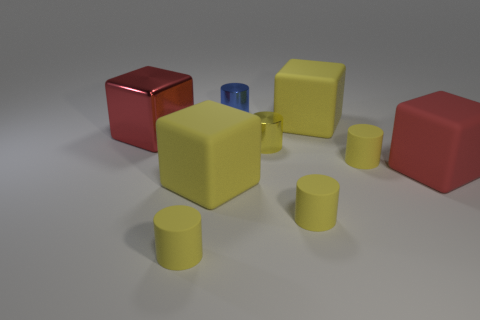How many yellow cylinders must be subtracted to get 1 yellow cylinders? 3 Subtract all cyan balls. How many yellow cylinders are left? 4 Subtract all blue cylinders. How many cylinders are left? 4 Subtract all blue shiny cylinders. How many cylinders are left? 4 Subtract all cyan cylinders. Subtract all green cubes. How many cylinders are left? 5 Add 1 large red cubes. How many objects exist? 10 Subtract all cubes. How many objects are left? 5 Add 8 large yellow matte objects. How many large yellow matte objects exist? 10 Subtract 0 green blocks. How many objects are left? 9 Subtract all yellow cylinders. Subtract all yellow matte cubes. How many objects are left? 3 